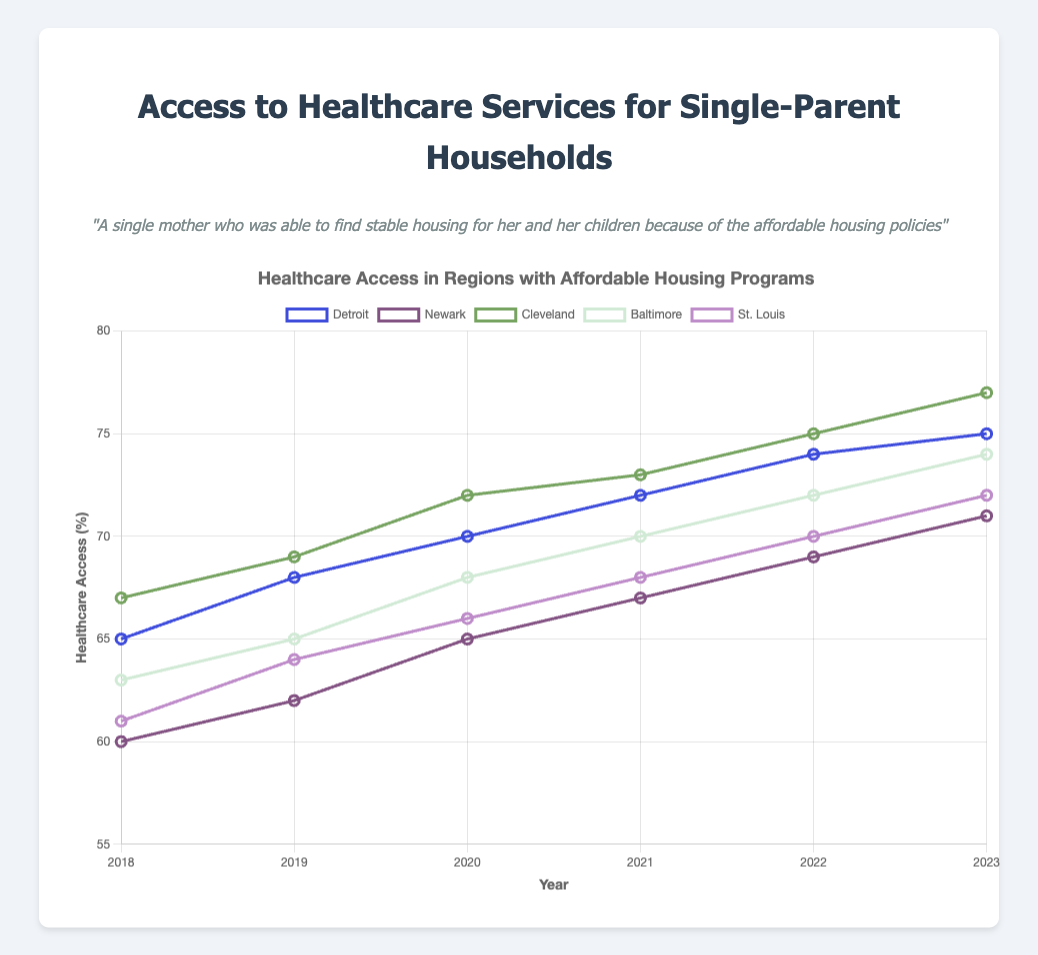what region had the highest healthcare access percentage in 2023? The figure shows healthcare access percentages for different regions over the years. In 2023, Cleveland had the highest value at 77%.
Answer: Cleveland Which region showed the most significant increase in healthcare access from 2018 to 2023? Calculate the difference in healthcare access between 2018 and 2023 for each region. It is: Detroit (75-65=10), Newark (71-60=11), Cleveland (77-67=10), Baltimore (74-63=11), and St. Louis (72-61=11). Baltimore, Newark, and St. Louis have the highest increase of 11%.
Answer: Baltimore, Newark, and St. Louis what was the healthcare access percentage for Detroit in 2020 and how does it compare to Newark in the same year? Refer to the figure for the year 2020. Detroit had a healthcare access of 70%, whereas Newark had 65%. Detroit’s percentage was higher.
Answer: Detroit had 70%, Newark had 65% Calculate the average healthcare access percentage in 2021 across all regions. Sum the 2021 data for all regions: (72 + 67 + 73 + 70 + 68) = 350. Divide by the number of regions (5) to get the average: 350/5 = 70.
Answer: 70 Did any region experience a decrease in healthcare access between any two consecutive years shown in the chart? Examine the trends for each region. All regions' healthcare access percentages either increased or remained the same every year from 2018 to 2023. No region experienced a decrease.
Answer: No Compare the healthcare access percentage trend for Cleveland and St. Louis from 2018 to 2023. Both Cleveland and St. Louis show an upward trend: Cleveland increases from 67% to 77%, and St. Louis from 61% to 72%. While both regions have improved, Cleveland's healthcare access percentage is consistently higher.
Answer: Both show upward trends, Cleveland is consistently higher In what year did Baltimore reach a healthcare access percentage of 70%? Refer to the figure for Baltimore's data points. In 2021, Baltimore reached 70%.
Answer: 2021 What is the difference between the highest and lowest healthcare access percentages across all regions in 2023? The highest is Cleveland at 77%, and the lowest is Newark at 71%. The difference is 77 - 71 = 6.
Answer: 6 